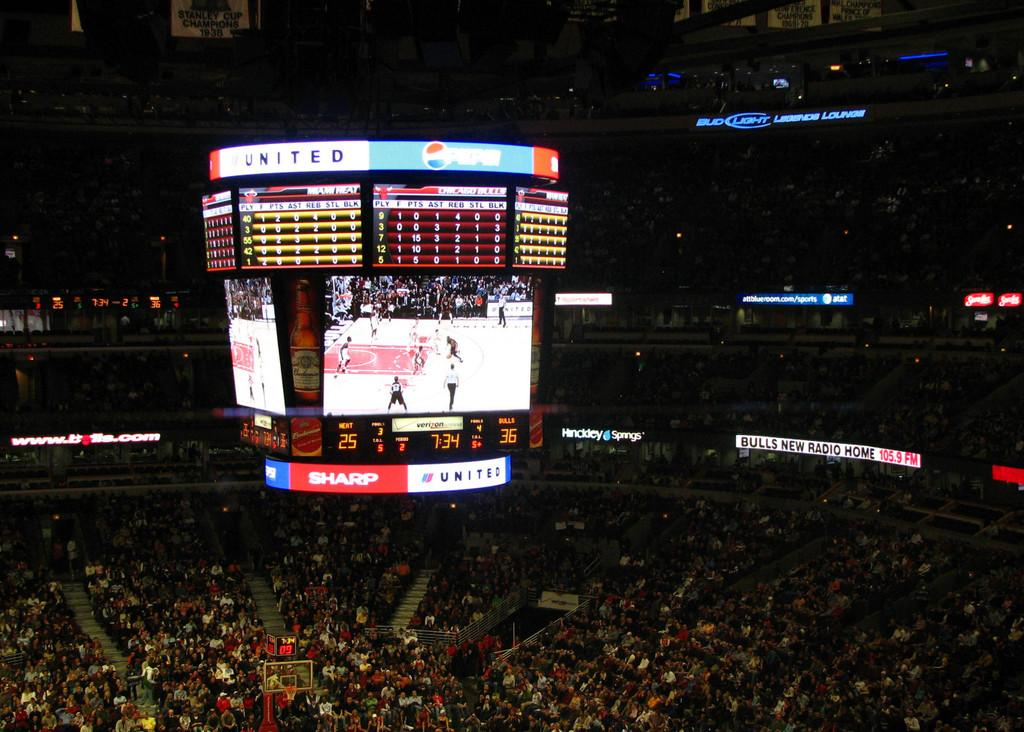<image>
Present a compact description of the photo's key features. Scoreboard at a basketball game showing an advertisement for Pepsi. 